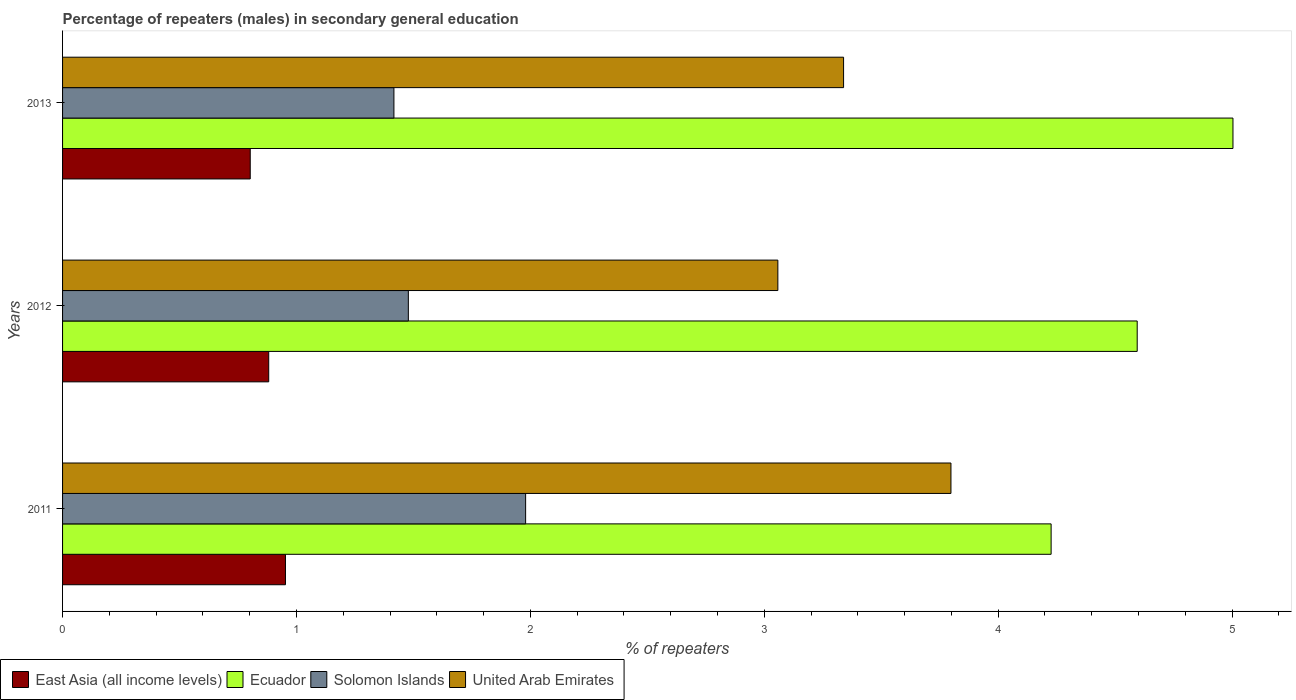How many different coloured bars are there?
Your answer should be compact. 4. Are the number of bars per tick equal to the number of legend labels?
Provide a succinct answer. Yes. What is the percentage of male repeaters in Solomon Islands in 2012?
Offer a terse response. 1.48. Across all years, what is the maximum percentage of male repeaters in Solomon Islands?
Ensure brevity in your answer.  1.98. Across all years, what is the minimum percentage of male repeaters in East Asia (all income levels)?
Offer a very short reply. 0.8. In which year was the percentage of male repeaters in East Asia (all income levels) maximum?
Ensure brevity in your answer.  2011. In which year was the percentage of male repeaters in United Arab Emirates minimum?
Keep it short and to the point. 2012. What is the total percentage of male repeaters in East Asia (all income levels) in the graph?
Your answer should be very brief. 2.64. What is the difference between the percentage of male repeaters in Solomon Islands in 2011 and that in 2012?
Your answer should be compact. 0.5. What is the difference between the percentage of male repeaters in United Arab Emirates in 2011 and the percentage of male repeaters in Ecuador in 2012?
Offer a very short reply. -0.8. What is the average percentage of male repeaters in Ecuador per year?
Give a very brief answer. 4.61. In the year 2012, what is the difference between the percentage of male repeaters in United Arab Emirates and percentage of male repeaters in East Asia (all income levels)?
Offer a very short reply. 2.18. In how many years, is the percentage of male repeaters in East Asia (all income levels) greater than 1.8 %?
Your answer should be compact. 0. What is the ratio of the percentage of male repeaters in East Asia (all income levels) in 2011 to that in 2013?
Ensure brevity in your answer.  1.19. Is the percentage of male repeaters in East Asia (all income levels) in 2011 less than that in 2013?
Keep it short and to the point. No. Is the difference between the percentage of male repeaters in United Arab Emirates in 2012 and 2013 greater than the difference between the percentage of male repeaters in East Asia (all income levels) in 2012 and 2013?
Give a very brief answer. No. What is the difference between the highest and the second highest percentage of male repeaters in Ecuador?
Provide a succinct answer. 0.41. What is the difference between the highest and the lowest percentage of male repeaters in Ecuador?
Make the answer very short. 0.78. What does the 1st bar from the top in 2013 represents?
Your response must be concise. United Arab Emirates. What does the 2nd bar from the bottom in 2012 represents?
Provide a succinct answer. Ecuador. Is it the case that in every year, the sum of the percentage of male repeaters in United Arab Emirates and percentage of male repeaters in Ecuador is greater than the percentage of male repeaters in East Asia (all income levels)?
Your answer should be very brief. Yes. How many bars are there?
Offer a terse response. 12. Are the values on the major ticks of X-axis written in scientific E-notation?
Make the answer very short. No. Does the graph contain any zero values?
Provide a short and direct response. No. Where does the legend appear in the graph?
Give a very brief answer. Bottom left. How many legend labels are there?
Your answer should be compact. 4. What is the title of the graph?
Your answer should be very brief. Percentage of repeaters (males) in secondary general education. Does "Sao Tome and Principe" appear as one of the legend labels in the graph?
Your answer should be very brief. No. What is the label or title of the X-axis?
Your answer should be compact. % of repeaters. What is the label or title of the Y-axis?
Ensure brevity in your answer.  Years. What is the % of repeaters in East Asia (all income levels) in 2011?
Keep it short and to the point. 0.95. What is the % of repeaters in Ecuador in 2011?
Your response must be concise. 4.23. What is the % of repeaters of Solomon Islands in 2011?
Your answer should be compact. 1.98. What is the % of repeaters of United Arab Emirates in 2011?
Your answer should be very brief. 3.8. What is the % of repeaters in East Asia (all income levels) in 2012?
Keep it short and to the point. 0.88. What is the % of repeaters in Ecuador in 2012?
Keep it short and to the point. 4.59. What is the % of repeaters of Solomon Islands in 2012?
Your answer should be compact. 1.48. What is the % of repeaters in United Arab Emirates in 2012?
Give a very brief answer. 3.06. What is the % of repeaters in East Asia (all income levels) in 2013?
Give a very brief answer. 0.8. What is the % of repeaters in Ecuador in 2013?
Your response must be concise. 5. What is the % of repeaters of Solomon Islands in 2013?
Your answer should be very brief. 1.42. What is the % of repeaters of United Arab Emirates in 2013?
Your answer should be compact. 3.34. Across all years, what is the maximum % of repeaters of East Asia (all income levels)?
Your answer should be very brief. 0.95. Across all years, what is the maximum % of repeaters of Ecuador?
Your answer should be compact. 5. Across all years, what is the maximum % of repeaters of Solomon Islands?
Give a very brief answer. 1.98. Across all years, what is the maximum % of repeaters of United Arab Emirates?
Your answer should be compact. 3.8. Across all years, what is the minimum % of repeaters of East Asia (all income levels)?
Make the answer very short. 0.8. Across all years, what is the minimum % of repeaters of Ecuador?
Provide a short and direct response. 4.23. Across all years, what is the minimum % of repeaters in Solomon Islands?
Your answer should be compact. 1.42. Across all years, what is the minimum % of repeaters of United Arab Emirates?
Your response must be concise. 3.06. What is the total % of repeaters of East Asia (all income levels) in the graph?
Provide a short and direct response. 2.64. What is the total % of repeaters of Ecuador in the graph?
Your answer should be compact. 13.82. What is the total % of repeaters in Solomon Islands in the graph?
Ensure brevity in your answer.  4.87. What is the total % of repeaters in United Arab Emirates in the graph?
Ensure brevity in your answer.  10.2. What is the difference between the % of repeaters of East Asia (all income levels) in 2011 and that in 2012?
Keep it short and to the point. 0.07. What is the difference between the % of repeaters of Ecuador in 2011 and that in 2012?
Provide a short and direct response. -0.37. What is the difference between the % of repeaters of Solomon Islands in 2011 and that in 2012?
Offer a very short reply. 0.5. What is the difference between the % of repeaters of United Arab Emirates in 2011 and that in 2012?
Offer a terse response. 0.74. What is the difference between the % of repeaters of East Asia (all income levels) in 2011 and that in 2013?
Provide a succinct answer. 0.15. What is the difference between the % of repeaters in Ecuador in 2011 and that in 2013?
Provide a succinct answer. -0.78. What is the difference between the % of repeaters in Solomon Islands in 2011 and that in 2013?
Provide a succinct answer. 0.56. What is the difference between the % of repeaters of United Arab Emirates in 2011 and that in 2013?
Provide a short and direct response. 0.46. What is the difference between the % of repeaters in East Asia (all income levels) in 2012 and that in 2013?
Your answer should be compact. 0.08. What is the difference between the % of repeaters in Ecuador in 2012 and that in 2013?
Offer a very short reply. -0.41. What is the difference between the % of repeaters in Solomon Islands in 2012 and that in 2013?
Your response must be concise. 0.06. What is the difference between the % of repeaters in United Arab Emirates in 2012 and that in 2013?
Provide a succinct answer. -0.28. What is the difference between the % of repeaters in East Asia (all income levels) in 2011 and the % of repeaters in Ecuador in 2012?
Offer a very short reply. -3.64. What is the difference between the % of repeaters in East Asia (all income levels) in 2011 and the % of repeaters in Solomon Islands in 2012?
Keep it short and to the point. -0.53. What is the difference between the % of repeaters in East Asia (all income levels) in 2011 and the % of repeaters in United Arab Emirates in 2012?
Provide a short and direct response. -2.11. What is the difference between the % of repeaters in Ecuador in 2011 and the % of repeaters in Solomon Islands in 2012?
Ensure brevity in your answer.  2.75. What is the difference between the % of repeaters in Ecuador in 2011 and the % of repeaters in United Arab Emirates in 2012?
Provide a short and direct response. 1.17. What is the difference between the % of repeaters of Solomon Islands in 2011 and the % of repeaters of United Arab Emirates in 2012?
Ensure brevity in your answer.  -1.08. What is the difference between the % of repeaters in East Asia (all income levels) in 2011 and the % of repeaters in Ecuador in 2013?
Provide a succinct answer. -4.05. What is the difference between the % of repeaters in East Asia (all income levels) in 2011 and the % of repeaters in Solomon Islands in 2013?
Make the answer very short. -0.46. What is the difference between the % of repeaters in East Asia (all income levels) in 2011 and the % of repeaters in United Arab Emirates in 2013?
Make the answer very short. -2.39. What is the difference between the % of repeaters in Ecuador in 2011 and the % of repeaters in Solomon Islands in 2013?
Keep it short and to the point. 2.81. What is the difference between the % of repeaters in Ecuador in 2011 and the % of repeaters in United Arab Emirates in 2013?
Offer a terse response. 0.89. What is the difference between the % of repeaters of Solomon Islands in 2011 and the % of repeaters of United Arab Emirates in 2013?
Make the answer very short. -1.36. What is the difference between the % of repeaters in East Asia (all income levels) in 2012 and the % of repeaters in Ecuador in 2013?
Offer a very short reply. -4.12. What is the difference between the % of repeaters in East Asia (all income levels) in 2012 and the % of repeaters in Solomon Islands in 2013?
Ensure brevity in your answer.  -0.54. What is the difference between the % of repeaters in East Asia (all income levels) in 2012 and the % of repeaters in United Arab Emirates in 2013?
Ensure brevity in your answer.  -2.46. What is the difference between the % of repeaters of Ecuador in 2012 and the % of repeaters of Solomon Islands in 2013?
Your response must be concise. 3.18. What is the difference between the % of repeaters of Ecuador in 2012 and the % of repeaters of United Arab Emirates in 2013?
Offer a very short reply. 1.26. What is the difference between the % of repeaters of Solomon Islands in 2012 and the % of repeaters of United Arab Emirates in 2013?
Your answer should be very brief. -1.86. What is the average % of repeaters of East Asia (all income levels) per year?
Your answer should be compact. 0.88. What is the average % of repeaters of Ecuador per year?
Your answer should be very brief. 4.61. What is the average % of repeaters in Solomon Islands per year?
Provide a short and direct response. 1.62. What is the average % of repeaters in United Arab Emirates per year?
Give a very brief answer. 3.4. In the year 2011, what is the difference between the % of repeaters of East Asia (all income levels) and % of repeaters of Ecuador?
Your response must be concise. -3.27. In the year 2011, what is the difference between the % of repeaters in East Asia (all income levels) and % of repeaters in Solomon Islands?
Provide a succinct answer. -1.03. In the year 2011, what is the difference between the % of repeaters of East Asia (all income levels) and % of repeaters of United Arab Emirates?
Provide a succinct answer. -2.85. In the year 2011, what is the difference between the % of repeaters of Ecuador and % of repeaters of Solomon Islands?
Provide a succinct answer. 2.25. In the year 2011, what is the difference between the % of repeaters in Ecuador and % of repeaters in United Arab Emirates?
Keep it short and to the point. 0.43. In the year 2011, what is the difference between the % of repeaters in Solomon Islands and % of repeaters in United Arab Emirates?
Your response must be concise. -1.82. In the year 2012, what is the difference between the % of repeaters of East Asia (all income levels) and % of repeaters of Ecuador?
Your answer should be compact. -3.71. In the year 2012, what is the difference between the % of repeaters of East Asia (all income levels) and % of repeaters of Solomon Islands?
Offer a terse response. -0.6. In the year 2012, what is the difference between the % of repeaters in East Asia (all income levels) and % of repeaters in United Arab Emirates?
Ensure brevity in your answer.  -2.18. In the year 2012, what is the difference between the % of repeaters in Ecuador and % of repeaters in Solomon Islands?
Provide a succinct answer. 3.12. In the year 2012, what is the difference between the % of repeaters of Ecuador and % of repeaters of United Arab Emirates?
Offer a very short reply. 1.54. In the year 2012, what is the difference between the % of repeaters in Solomon Islands and % of repeaters in United Arab Emirates?
Your response must be concise. -1.58. In the year 2013, what is the difference between the % of repeaters of East Asia (all income levels) and % of repeaters of Ecuador?
Offer a terse response. -4.2. In the year 2013, what is the difference between the % of repeaters of East Asia (all income levels) and % of repeaters of Solomon Islands?
Keep it short and to the point. -0.61. In the year 2013, what is the difference between the % of repeaters in East Asia (all income levels) and % of repeaters in United Arab Emirates?
Provide a short and direct response. -2.54. In the year 2013, what is the difference between the % of repeaters in Ecuador and % of repeaters in Solomon Islands?
Your answer should be compact. 3.59. In the year 2013, what is the difference between the % of repeaters of Ecuador and % of repeaters of United Arab Emirates?
Provide a short and direct response. 1.66. In the year 2013, what is the difference between the % of repeaters of Solomon Islands and % of repeaters of United Arab Emirates?
Offer a very short reply. -1.92. What is the ratio of the % of repeaters of East Asia (all income levels) in 2011 to that in 2012?
Keep it short and to the point. 1.08. What is the ratio of the % of repeaters in Ecuador in 2011 to that in 2012?
Your answer should be compact. 0.92. What is the ratio of the % of repeaters in Solomon Islands in 2011 to that in 2012?
Your answer should be compact. 1.34. What is the ratio of the % of repeaters of United Arab Emirates in 2011 to that in 2012?
Make the answer very short. 1.24. What is the ratio of the % of repeaters in East Asia (all income levels) in 2011 to that in 2013?
Provide a succinct answer. 1.19. What is the ratio of the % of repeaters in Ecuador in 2011 to that in 2013?
Your answer should be compact. 0.84. What is the ratio of the % of repeaters of Solomon Islands in 2011 to that in 2013?
Ensure brevity in your answer.  1.4. What is the ratio of the % of repeaters in United Arab Emirates in 2011 to that in 2013?
Keep it short and to the point. 1.14. What is the ratio of the % of repeaters of East Asia (all income levels) in 2012 to that in 2013?
Keep it short and to the point. 1.1. What is the ratio of the % of repeaters in Ecuador in 2012 to that in 2013?
Offer a very short reply. 0.92. What is the ratio of the % of repeaters in Solomon Islands in 2012 to that in 2013?
Provide a succinct answer. 1.04. What is the ratio of the % of repeaters in United Arab Emirates in 2012 to that in 2013?
Give a very brief answer. 0.92. What is the difference between the highest and the second highest % of repeaters in East Asia (all income levels)?
Ensure brevity in your answer.  0.07. What is the difference between the highest and the second highest % of repeaters in Ecuador?
Your response must be concise. 0.41. What is the difference between the highest and the second highest % of repeaters of Solomon Islands?
Offer a terse response. 0.5. What is the difference between the highest and the second highest % of repeaters in United Arab Emirates?
Keep it short and to the point. 0.46. What is the difference between the highest and the lowest % of repeaters in East Asia (all income levels)?
Ensure brevity in your answer.  0.15. What is the difference between the highest and the lowest % of repeaters in Ecuador?
Ensure brevity in your answer.  0.78. What is the difference between the highest and the lowest % of repeaters in Solomon Islands?
Your answer should be very brief. 0.56. What is the difference between the highest and the lowest % of repeaters in United Arab Emirates?
Offer a very short reply. 0.74. 